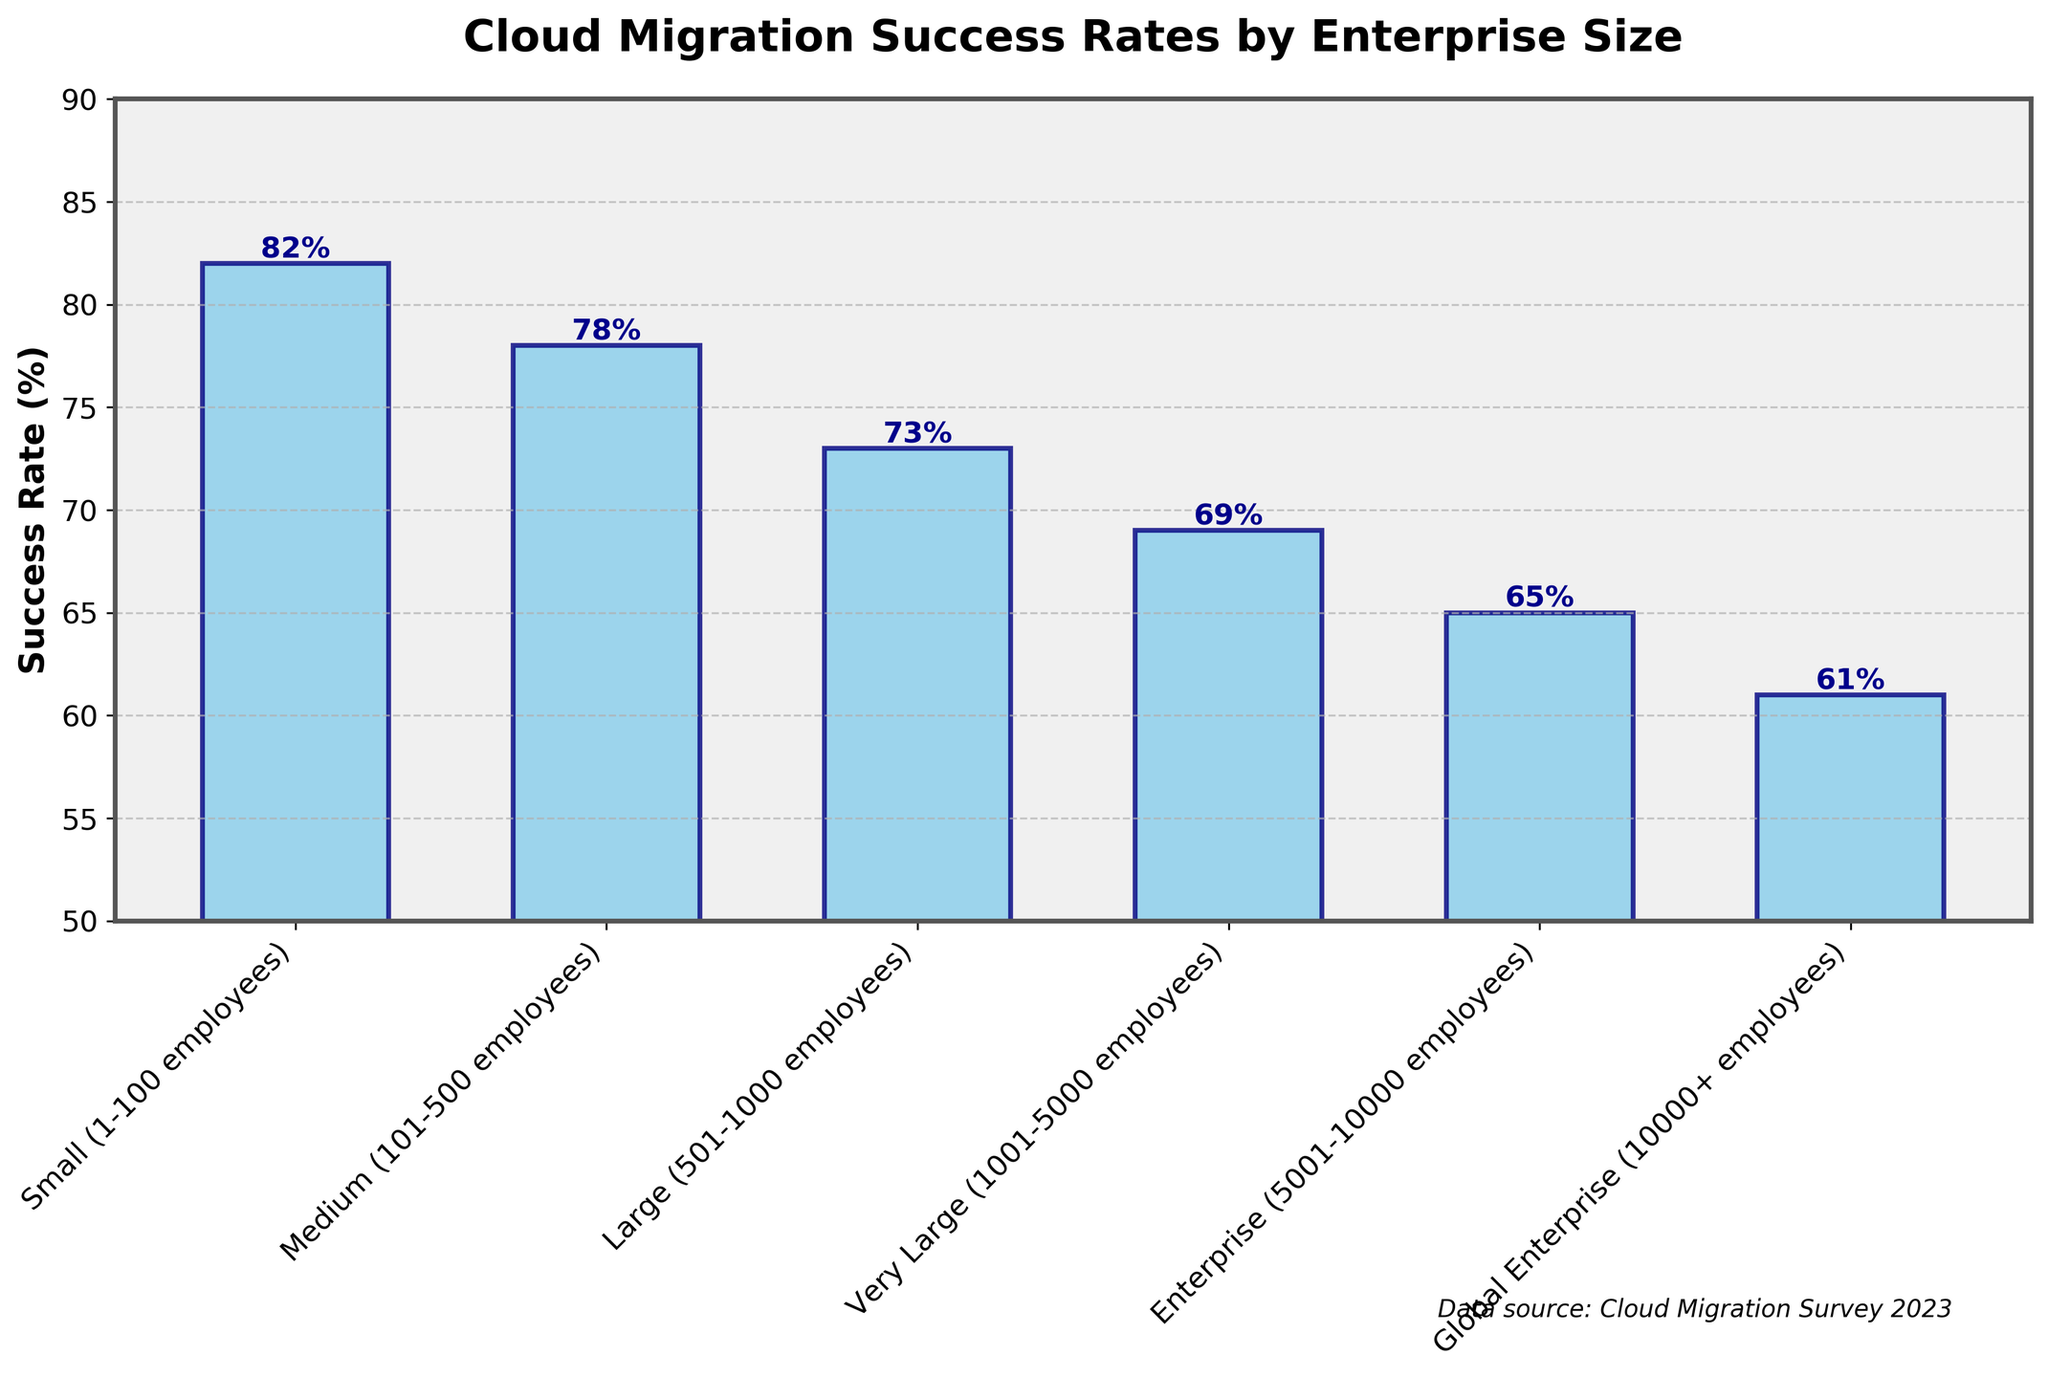What is the cloud migration success rate for medium-sized enterprises? The bar corresponding to "Medium (101-500 employees)" shows the cloud migration success rate directly on top of it: 78%.
Answer: 78% Which enterprise size has the highest cloud migration success rate? By observing the bar heights, the "Small (1-100 employees)" category has the highest bar, indicating it has the highest success rate at 82%.
Answer: Small (1-100 employees) By how many percentage points is the cloud migration success rate of large enterprises lower than that of small enterprises? The success rate for "Large (501-1000 employees)" is 73%, and for "Small (1-100 employees)" it is 82%. The difference is 82% - 73% = 9%.
Answer: 9% Which enterprise size has the lowest cloud migration success rate? The shortest bar belongs to "Global Enterprise (10000+ employees)", indicating the lowest success rate of 61%.
Answer: Global Enterprise (10000+ employees) What is the average cloud migration success rate for all enterprise sizes? Summing all success rates: 82 + 78 + 73 + 69 + 65 + 61 = 428. There are 6 categories, so the average is 428 / 6 = 71.33%.
Answer: 71.33% What is the median cloud migration success rate? Listing the success rates in ascending order: 61, 65, 69, 73, 78, 82. The median is the average of the middle two values (69 + 73) / 2 = 71%.
Answer: 71% Is the cloud migration success rate for very large enterprises higher or lower than that for medium enterprises? The success rate for "Very Large (1001-5000 employees)" is 69%, while for "Medium (101-500 employees)", it is 78%. 69% is lower than 78%.
Answer: Lower What pattern can be inferred from the cloud migration success rates with increasing enterprise size? Observing the bar chart, the success rate decreases as the enterprise size increases.
Answer: Decreases as size increases What is the difference in success rate between the smallest and the largest enterprise sizes? The success rate for "Small (1-100 employees)" is 82%, and for "Global Enterprise (10000+ employees)" it is 61%. The difference is 82% - 61% = 21%.
Answer: 21% Which enterprise sizes have a cloud migration success rate lower than 70%? From the bars, the categories "Very Large (1001-5000 employees)", "Enterprise (5001-10000 employees)", and "Global Enterprise (10000+ employees)" have success rates below 70%: 69%, 65%, and 61% respectively.
Answer: Very Large, Enterprise, Global Enterprise 